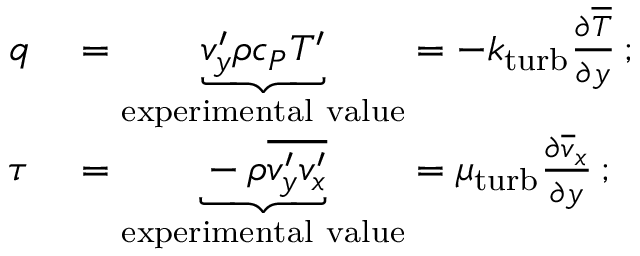<formula> <loc_0><loc_0><loc_500><loc_500>\begin{array} { r l } { q } & = \underbrace { v _ { y } ^ { \prime } \rho c _ { P } T ^ { \prime } } _ { e x p e r i m e n t a l v a l u e } = - k _ { t u r b } { \frac { \partial { \overline { T } } } { \partial y } } \, ; } \\ { \tau } & = \underbrace { - \rho { \overline { { v _ { y } ^ { \prime } v _ { x } ^ { \prime } } } } } _ { e x p e r i m e n t a l v a l u e } = \mu _ { t u r b } { \frac { \partial { \overline { v } } _ { x } } { \partial y } } \, ; } \end{array}</formula> 